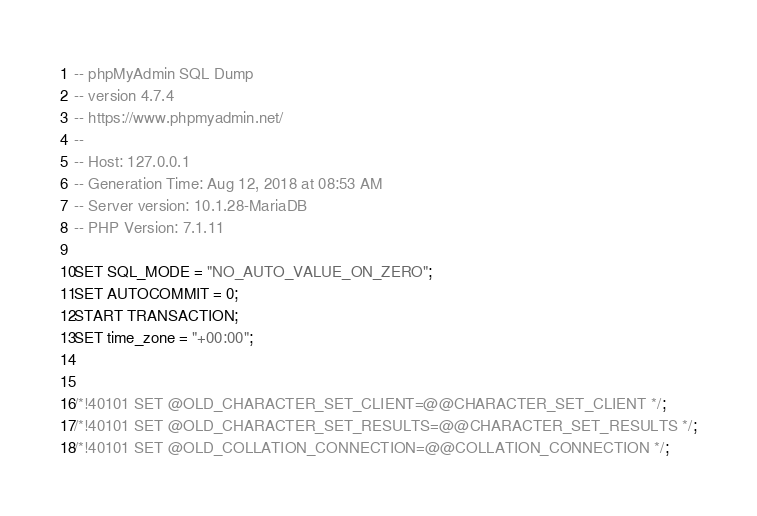<code> <loc_0><loc_0><loc_500><loc_500><_SQL_>-- phpMyAdmin SQL Dump
-- version 4.7.4
-- https://www.phpmyadmin.net/
--
-- Host: 127.0.0.1
-- Generation Time: Aug 12, 2018 at 08:53 AM
-- Server version: 10.1.28-MariaDB
-- PHP Version: 7.1.11

SET SQL_MODE = "NO_AUTO_VALUE_ON_ZERO";
SET AUTOCOMMIT = 0;
START TRANSACTION;
SET time_zone = "+00:00";


/*!40101 SET @OLD_CHARACTER_SET_CLIENT=@@CHARACTER_SET_CLIENT */;
/*!40101 SET @OLD_CHARACTER_SET_RESULTS=@@CHARACTER_SET_RESULTS */;
/*!40101 SET @OLD_COLLATION_CONNECTION=@@COLLATION_CONNECTION */;</code> 